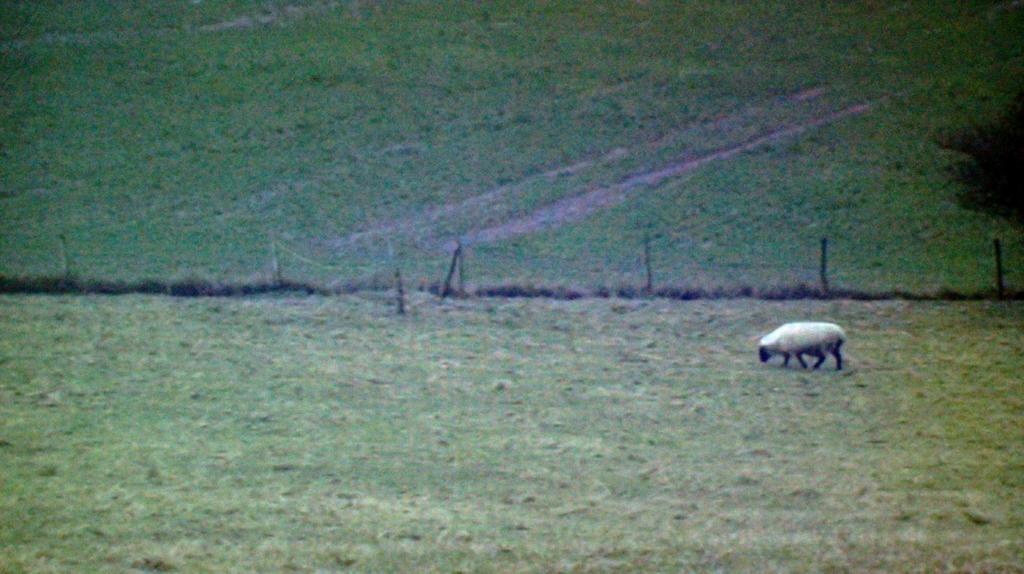In one or two sentences, can you explain what this image depicts? There is a big land filled with a lot of grass and a sheep is grazing the grass. 